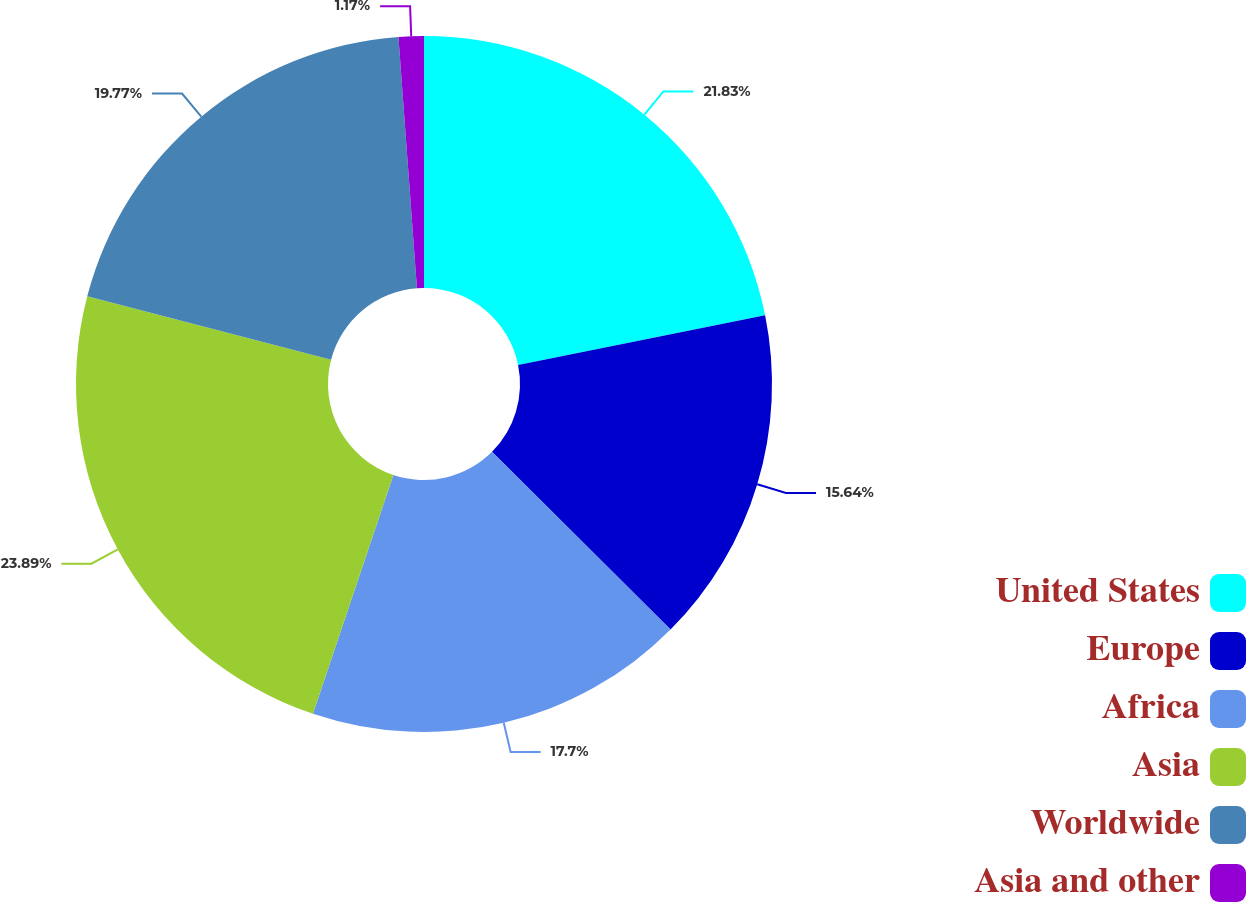<chart> <loc_0><loc_0><loc_500><loc_500><pie_chart><fcel>United States<fcel>Europe<fcel>Africa<fcel>Asia<fcel>Worldwide<fcel>Asia and other<nl><fcel>21.83%<fcel>15.64%<fcel>17.7%<fcel>23.89%<fcel>19.77%<fcel>1.17%<nl></chart> 